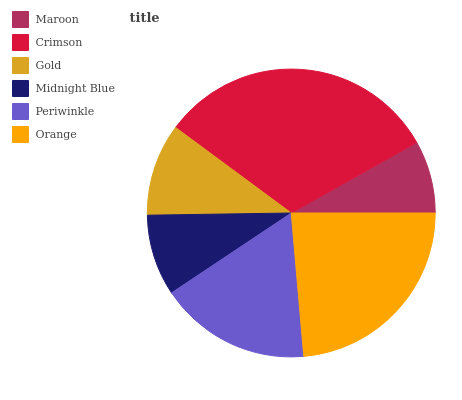Is Maroon the minimum?
Answer yes or no. Yes. Is Crimson the maximum?
Answer yes or no. Yes. Is Gold the minimum?
Answer yes or no. No. Is Gold the maximum?
Answer yes or no. No. Is Crimson greater than Gold?
Answer yes or no. Yes. Is Gold less than Crimson?
Answer yes or no. Yes. Is Gold greater than Crimson?
Answer yes or no. No. Is Crimson less than Gold?
Answer yes or no. No. Is Periwinkle the high median?
Answer yes or no. Yes. Is Gold the low median?
Answer yes or no. Yes. Is Maroon the high median?
Answer yes or no. No. Is Orange the low median?
Answer yes or no. No. 